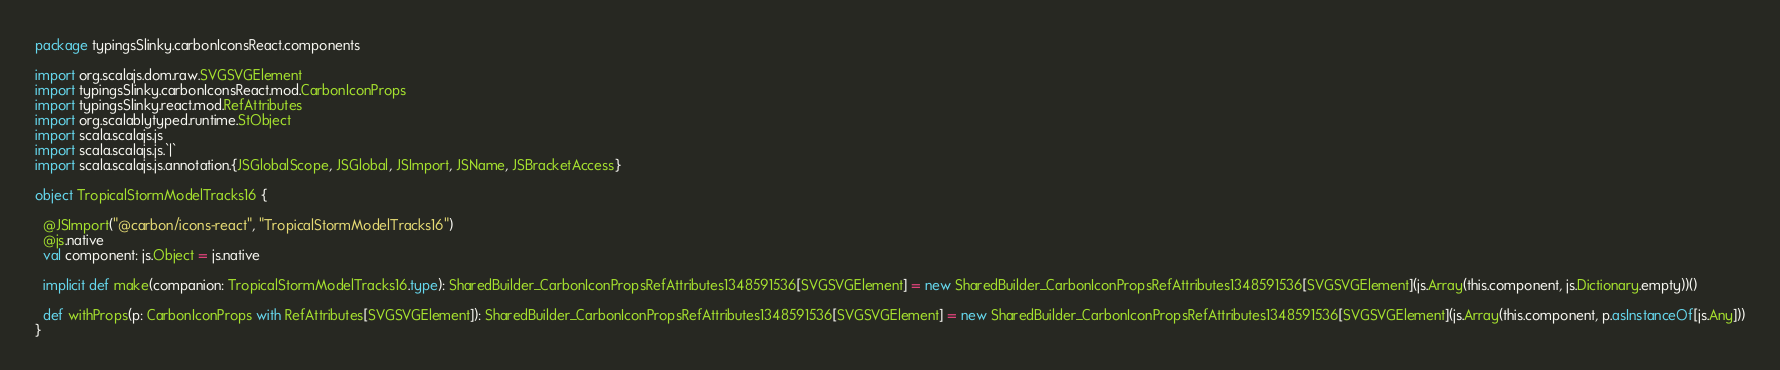<code> <loc_0><loc_0><loc_500><loc_500><_Scala_>package typingsSlinky.carbonIconsReact.components

import org.scalajs.dom.raw.SVGSVGElement
import typingsSlinky.carbonIconsReact.mod.CarbonIconProps
import typingsSlinky.react.mod.RefAttributes
import org.scalablytyped.runtime.StObject
import scala.scalajs.js
import scala.scalajs.js.`|`
import scala.scalajs.js.annotation.{JSGlobalScope, JSGlobal, JSImport, JSName, JSBracketAccess}

object TropicalStormModelTracks16 {
  
  @JSImport("@carbon/icons-react", "TropicalStormModelTracks16")
  @js.native
  val component: js.Object = js.native
  
  implicit def make(companion: TropicalStormModelTracks16.type): SharedBuilder_CarbonIconPropsRefAttributes1348591536[SVGSVGElement] = new SharedBuilder_CarbonIconPropsRefAttributes1348591536[SVGSVGElement](js.Array(this.component, js.Dictionary.empty))()
  
  def withProps(p: CarbonIconProps with RefAttributes[SVGSVGElement]): SharedBuilder_CarbonIconPropsRefAttributes1348591536[SVGSVGElement] = new SharedBuilder_CarbonIconPropsRefAttributes1348591536[SVGSVGElement](js.Array(this.component, p.asInstanceOf[js.Any]))
}
</code> 